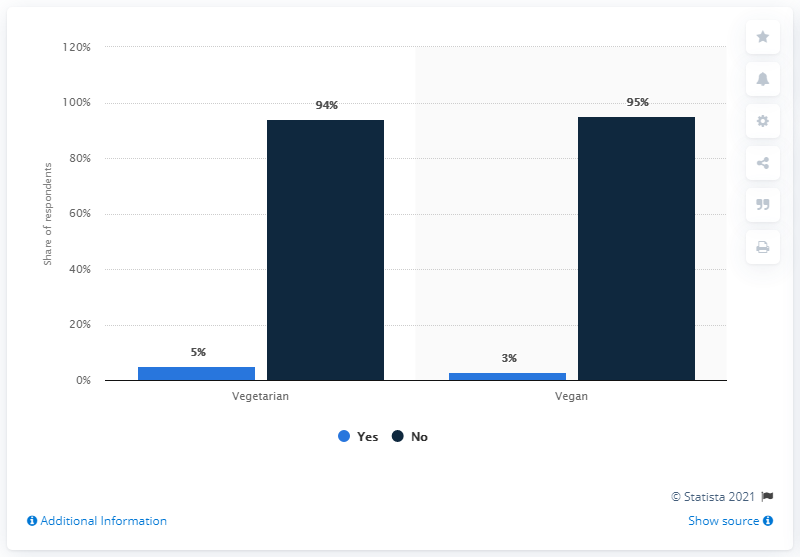List a handful of essential elements in this visual. The average of no vegetarian and no vegan together is 94.5. Veganism indicates the highest percentage among the given options, followed by lacto-ovo-vegetarianism and pescetarianism. 